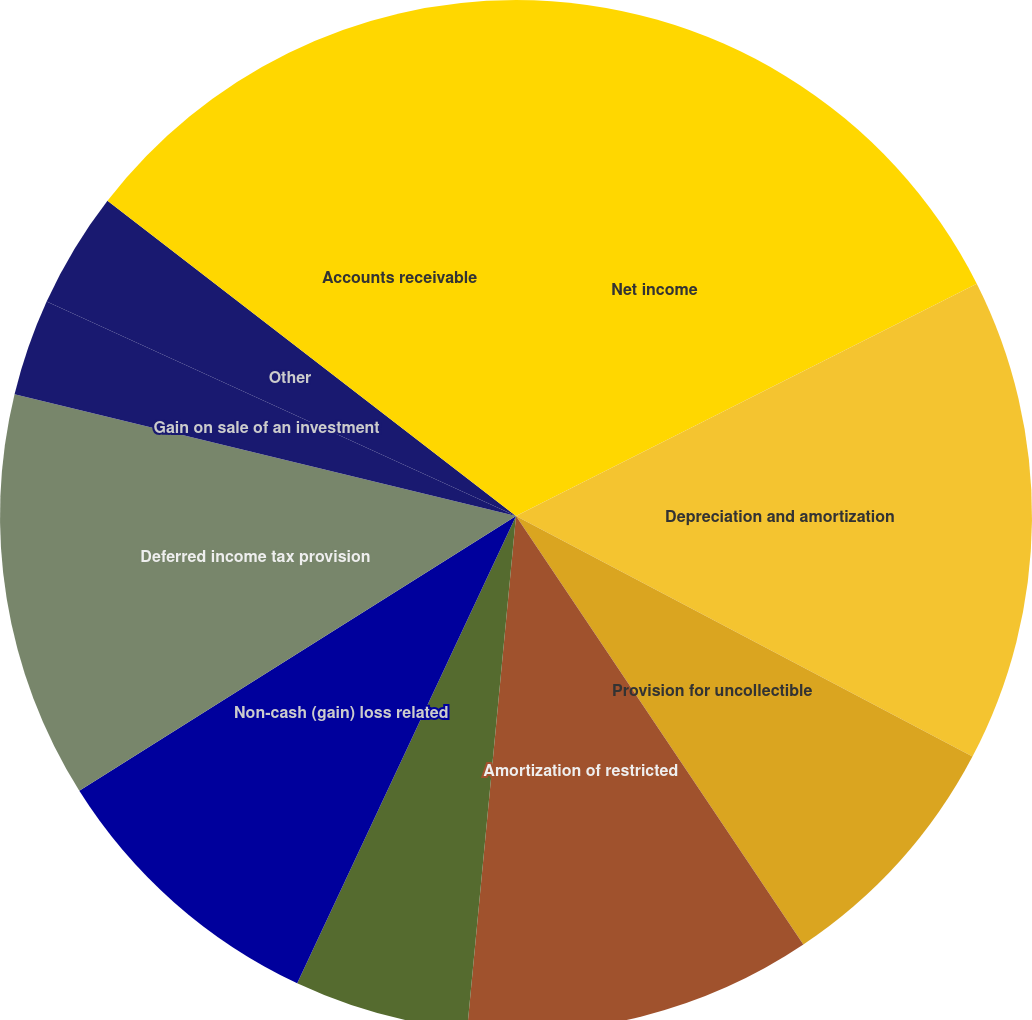Convert chart to OTSL. <chart><loc_0><loc_0><loc_500><loc_500><pie_chart><fcel>Net income<fcel>Depreciation and amortization<fcel>Provision for uncollectible<fcel>Amortization of restricted<fcel>Net amortization of bond<fcel>Non-cash (gain) loss related<fcel>Deferred income tax provision<fcel>Gain on sale of an investment<fcel>Other<fcel>Accounts receivable<nl><fcel>17.57%<fcel>15.15%<fcel>7.88%<fcel>10.91%<fcel>5.46%<fcel>9.09%<fcel>12.73%<fcel>3.03%<fcel>3.64%<fcel>14.54%<nl></chart> 